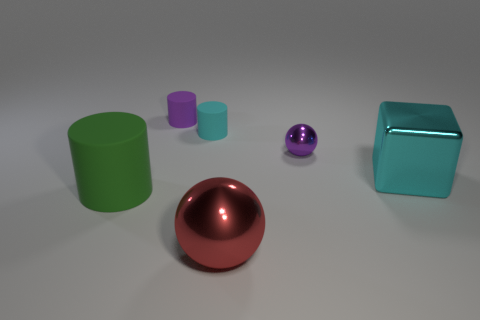Subtract all small matte cylinders. How many cylinders are left? 1 Subtract all purple cylinders. How many cylinders are left? 2 Subtract 1 spheres. How many spheres are left? 1 Add 1 tiny purple cylinders. How many objects exist? 7 Subtract all blocks. How many objects are left? 5 Subtract 0 purple cubes. How many objects are left? 6 Subtract all blue cubes. Subtract all blue spheres. How many cubes are left? 1 Subtract all big green cylinders. Subtract all small brown matte cylinders. How many objects are left? 5 Add 2 small cylinders. How many small cylinders are left? 4 Add 4 big matte cubes. How many big matte cubes exist? 4 